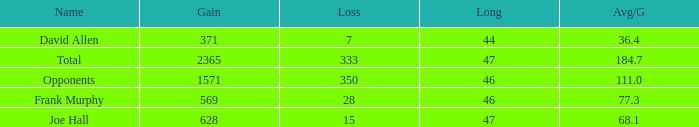Which Avg/G is the lowest one that has a Long smaller than 47, and a Name of frank murphy, and a Gain smaller than 569? None. 